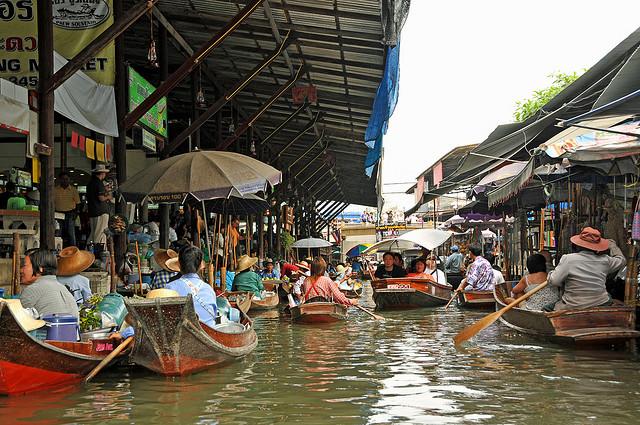What color is the paddle on the right?
Be succinct. Brown. What are these boats called?
Give a very brief answer. Canoes. Is it cloudy?
Quick response, please. Yes. 